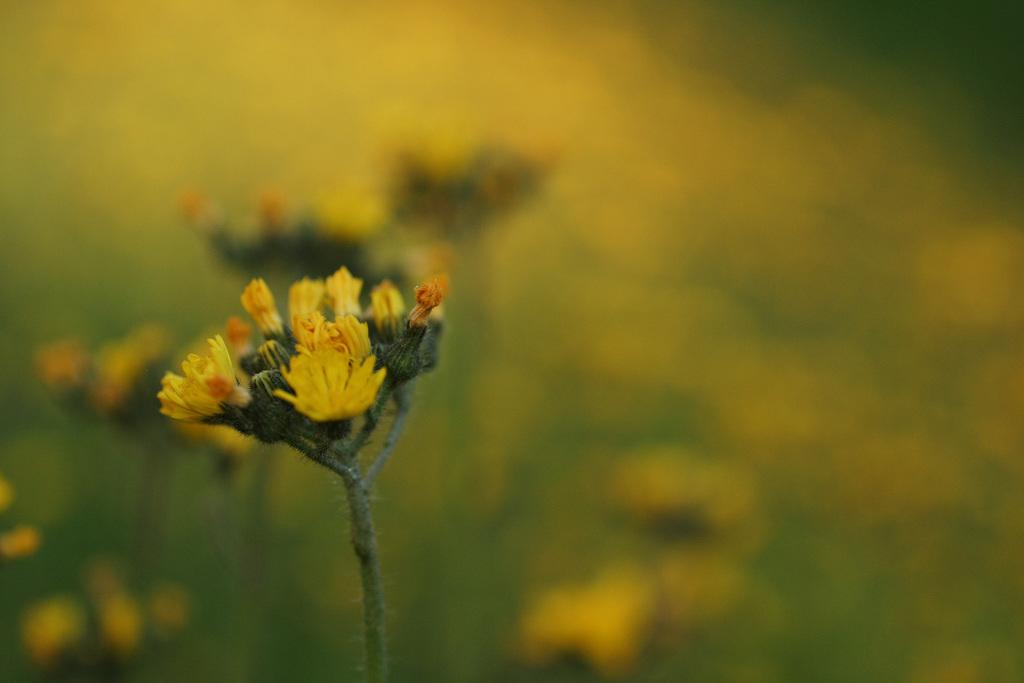What type of living organisms can be seen in the image? There are flowers in the image. What color are the flowers in the image? The flowers are in yellow color. What type of distribution system is visible in the image? There is no distribution system present in the image; it features flowers in yellow color. Can you see a kitty playing with a needle in the image? There is no kitty or needle present in the image. 